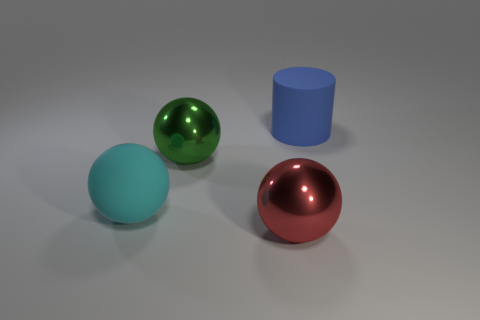Subtract all big metal balls. How many balls are left? 1 Add 1 red metal spheres. How many objects exist? 5 Subtract all cyan balls. How many balls are left? 2 Subtract 2 balls. How many balls are left? 1 Subtract all cylinders. How many objects are left? 3 Add 3 large blue things. How many large blue things exist? 4 Subtract 0 yellow cubes. How many objects are left? 4 Subtract all cyan balls. Subtract all red blocks. How many balls are left? 2 Subtract all cyan matte things. Subtract all big green metal spheres. How many objects are left? 2 Add 4 green metal objects. How many green metal objects are left? 5 